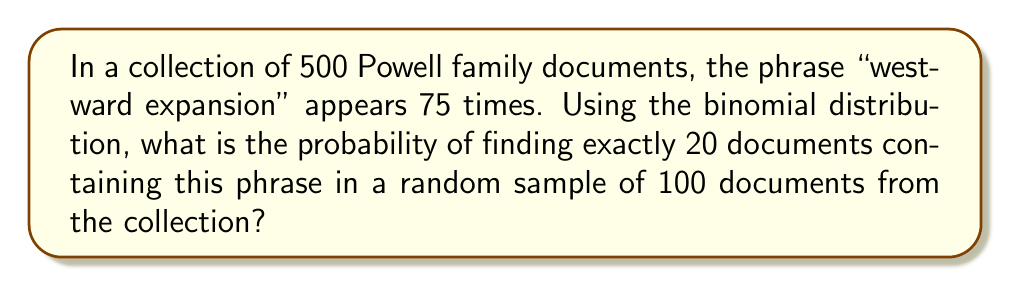What is the answer to this math problem? To solve this problem, we'll use the binomial probability formula:

$$P(X = k) = \binom{n}{k} p^k (1-p)^{n-k}$$

Where:
- $n$ is the number of trials (sample size)
- $k$ is the number of successes
- $p$ is the probability of success on each trial

Step 1: Calculate the probability of a document containing the phrase:
$p = \frac{75}{500} = 0.15$

Step 2: Identify the values for our formula:
- $n = 100$ (sample size)
- $k = 20$ (exact number of documents we're looking for)
- $p = 0.15$ (probability of success)

Step 3: Calculate the binomial coefficient:
$$\binom{100}{20} = \frac{100!}{20!(100-20)!} = 5.36 \times 10^{20}$$

Step 4: Apply the binomial probability formula:
$$P(X = 20) = \binom{100}{20} (0.15)^{20} (1-0.15)^{100-20}$$
$$= 5.36 \times 10^{20} \times (0.15)^{20} \times (0.85)^{80}$$

Step 5: Calculate the final result:
$$= 5.36 \times 10^{20} \times 3.19 \times 10^{-17} \times 1.03 \times 10^{-8}$$
$$= 0.0176$$

Therefore, the probability of finding exactly 20 documents containing the phrase "westward expansion" in a random sample of 100 documents is approximately 0.0176 or 1.76%.
Answer: 0.0176 